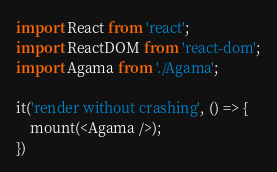Convert code to text. <code><loc_0><loc_0><loc_500><loc_500><_JavaScript_>import React from 'react';
import ReactDOM from 'react-dom';
import Agama from './Agama';

it('render without crashing', () => {
	mount(<Agama />);
})</code> 